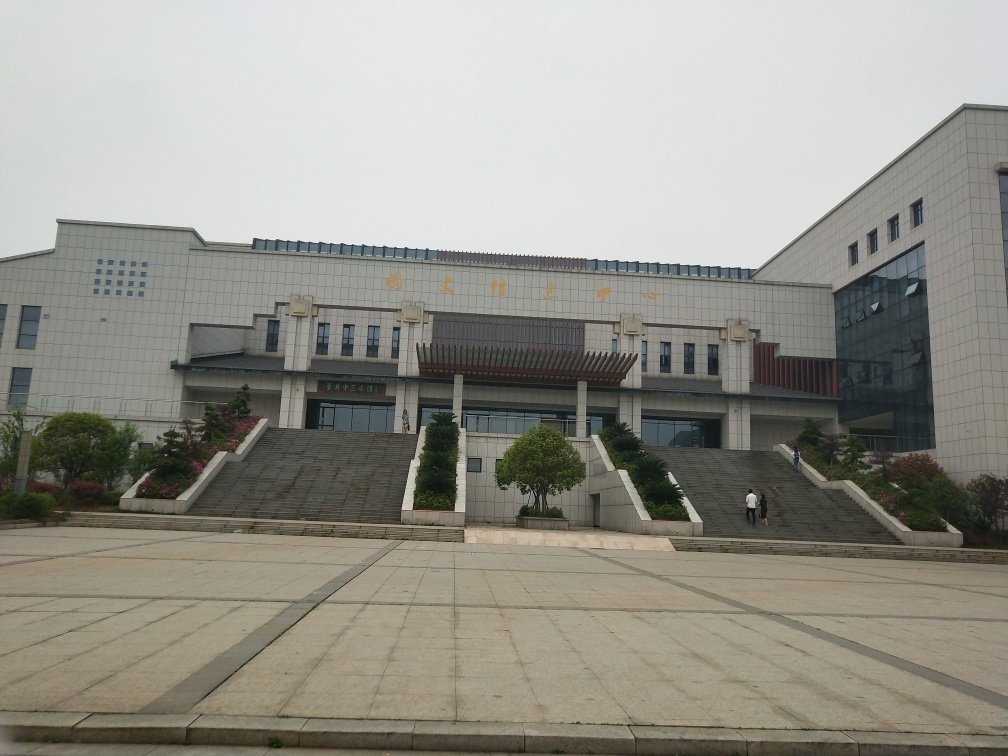What architectural style does the building in the image represent? The building features a modern architectural style with clean lines, a structured facade, and a balanced composition, suggesting an institutional or governmental function. 